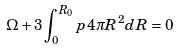<formula> <loc_0><loc_0><loc_500><loc_500>\Omega + 3 \int _ { 0 } ^ { R _ { 0 } } p 4 \pi R ^ { 2 } d R = 0</formula> 